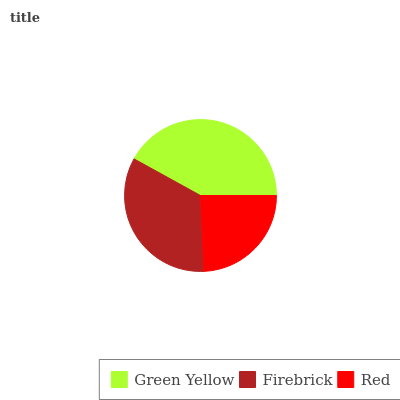Is Red the minimum?
Answer yes or no. Yes. Is Green Yellow the maximum?
Answer yes or no. Yes. Is Firebrick the minimum?
Answer yes or no. No. Is Firebrick the maximum?
Answer yes or no. No. Is Green Yellow greater than Firebrick?
Answer yes or no. Yes. Is Firebrick less than Green Yellow?
Answer yes or no. Yes. Is Firebrick greater than Green Yellow?
Answer yes or no. No. Is Green Yellow less than Firebrick?
Answer yes or no. No. Is Firebrick the high median?
Answer yes or no. Yes. Is Firebrick the low median?
Answer yes or no. Yes. Is Red the high median?
Answer yes or no. No. Is Green Yellow the low median?
Answer yes or no. No. 